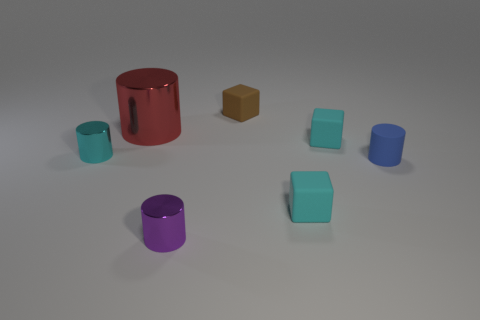Subtract all green cylinders. Subtract all red cubes. How many cylinders are left? 4 Add 2 brown rubber things. How many objects exist? 9 Subtract all blocks. How many objects are left? 4 Add 4 small cyan metal cylinders. How many small cyan metal cylinders exist? 5 Subtract 0 green spheres. How many objects are left? 7 Subtract all cyan cylinders. Subtract all small metal objects. How many objects are left? 4 Add 2 brown things. How many brown things are left? 3 